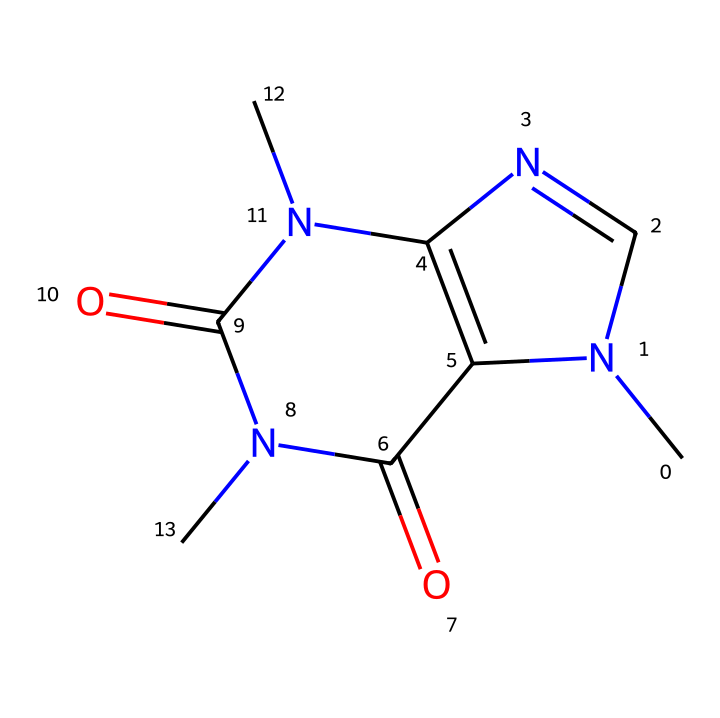What is the total number of nitrogen atoms in this chemical structure? By examining the SMILES representation, we count two "N" characters, indicating there are two nitrogen atoms in the chemical structure.
Answer: 2 How many carbon atoms are present in this molecule? The SMILES representation shows several "C" characters. Counting them reveals a total of eight carbon atoms in this structure.
Answer: 8 What type of chemical is represented by this structure? The presence of the nitrogen atoms and specific functional groups suggests it is a drug, specifically a stimulant known as caffeine.
Answer: stimulant Which functional groups can be found in this chemical? The structure contains amine groups (due to nitrogen) and carbonyl groups (indicated by the presence of "C(=O)"). These functional groups contribute to the molecule's properties.
Answer: amine and carbonyl How does this chemical affect human alertness? Caffeine is known to block adenosine receptors, which leads to increased alertness and reduced fatigue. This is primarily due to its molecular structure allowing it to fit into these receptors.
Answer: increases alertness What is the molecular formula derived from the structure? By counting all the elements represented in the SMILES, we can deduce the molecular formula as C8H10N4O2 for caffeine, which includes carbon, hydrogen, nitrogen, and oxygen.
Answer: C8H10N4O2 